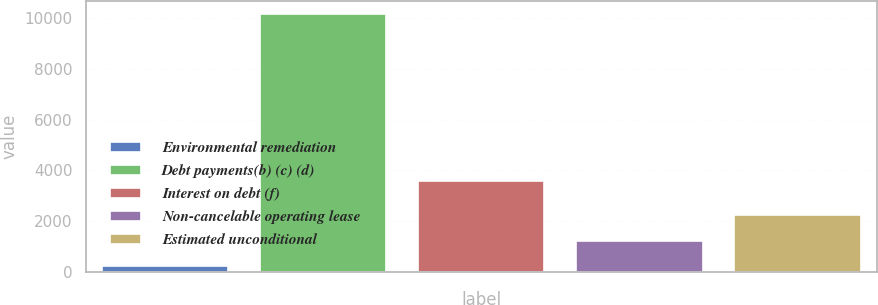<chart> <loc_0><loc_0><loc_500><loc_500><bar_chart><fcel>Environmental remediation<fcel>Debt payments(b) (c) (d)<fcel>Interest on debt (f)<fcel>Non-cancelable operating lease<fcel>Estimated unconditional<nl><fcel>241<fcel>10148<fcel>3583<fcel>1231.7<fcel>2222.4<nl></chart> 